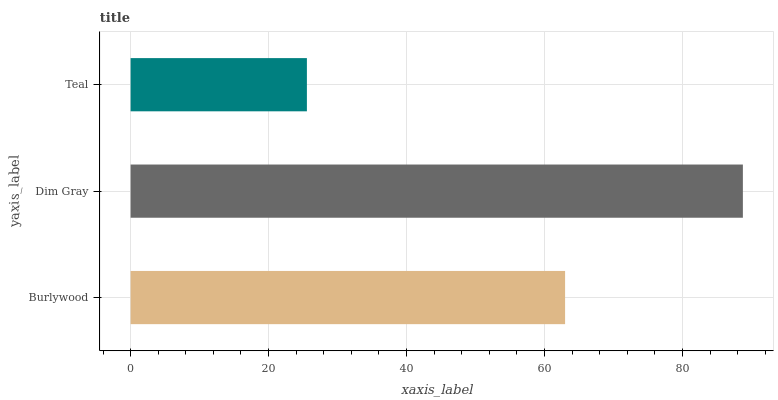Is Teal the minimum?
Answer yes or no. Yes. Is Dim Gray the maximum?
Answer yes or no. Yes. Is Dim Gray the minimum?
Answer yes or no. No. Is Teal the maximum?
Answer yes or no. No. Is Dim Gray greater than Teal?
Answer yes or no. Yes. Is Teal less than Dim Gray?
Answer yes or no. Yes. Is Teal greater than Dim Gray?
Answer yes or no. No. Is Dim Gray less than Teal?
Answer yes or no. No. Is Burlywood the high median?
Answer yes or no. Yes. Is Burlywood the low median?
Answer yes or no. Yes. Is Dim Gray the high median?
Answer yes or no. No. Is Dim Gray the low median?
Answer yes or no. No. 